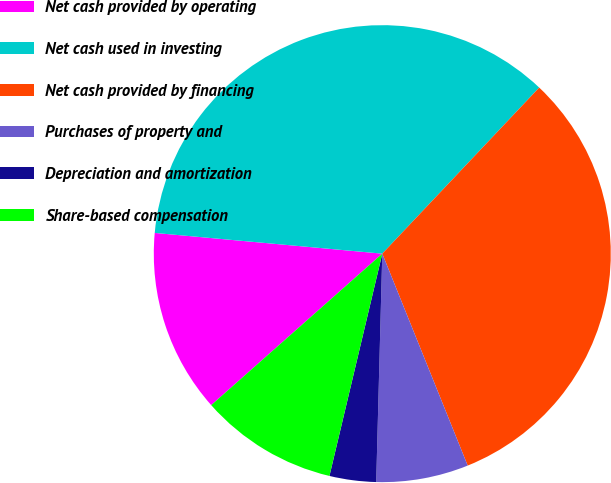Convert chart to OTSL. <chart><loc_0><loc_0><loc_500><loc_500><pie_chart><fcel>Net cash provided by operating<fcel>Net cash used in investing<fcel>Net cash provided by financing<fcel>Purchases of property and<fcel>Depreciation and amortization<fcel>Share-based compensation<nl><fcel>12.98%<fcel>35.6%<fcel>31.85%<fcel>6.52%<fcel>3.29%<fcel>9.75%<nl></chart> 